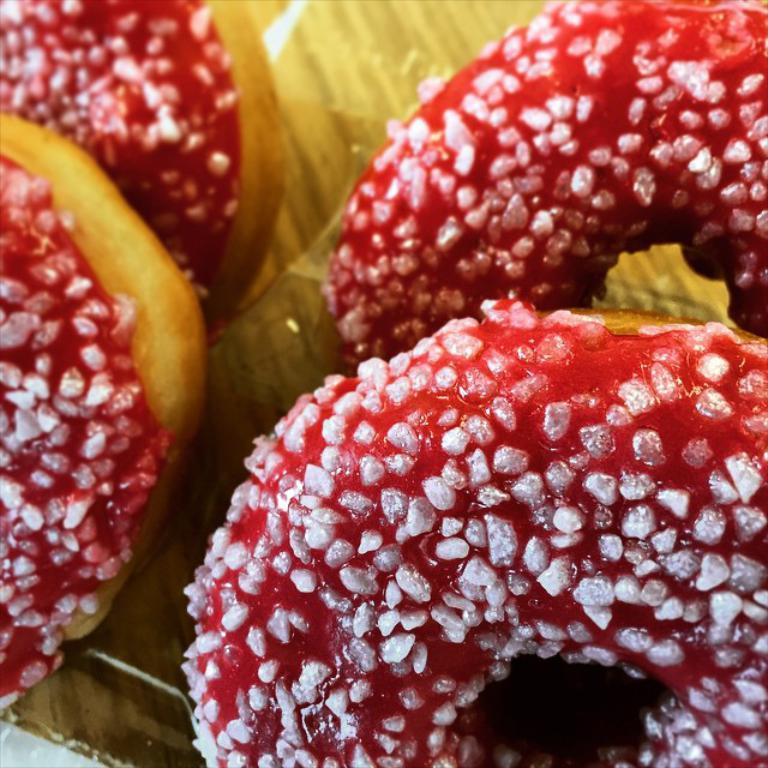What type of food is visible in the image? There are doughnuts in the image. Where are the doughnuts located? The doughnuts are placed on a surface. What type of reaction can be seen in the notebook in the image? There is no notebook present in the image, so no reaction can be seen. 